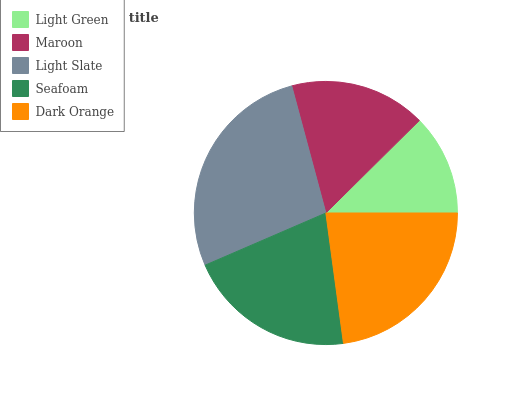Is Light Green the minimum?
Answer yes or no. Yes. Is Light Slate the maximum?
Answer yes or no. Yes. Is Maroon the minimum?
Answer yes or no. No. Is Maroon the maximum?
Answer yes or no. No. Is Maroon greater than Light Green?
Answer yes or no. Yes. Is Light Green less than Maroon?
Answer yes or no. Yes. Is Light Green greater than Maroon?
Answer yes or no. No. Is Maroon less than Light Green?
Answer yes or no. No. Is Seafoam the high median?
Answer yes or no. Yes. Is Seafoam the low median?
Answer yes or no. Yes. Is Light Green the high median?
Answer yes or no. No. Is Light Green the low median?
Answer yes or no. No. 